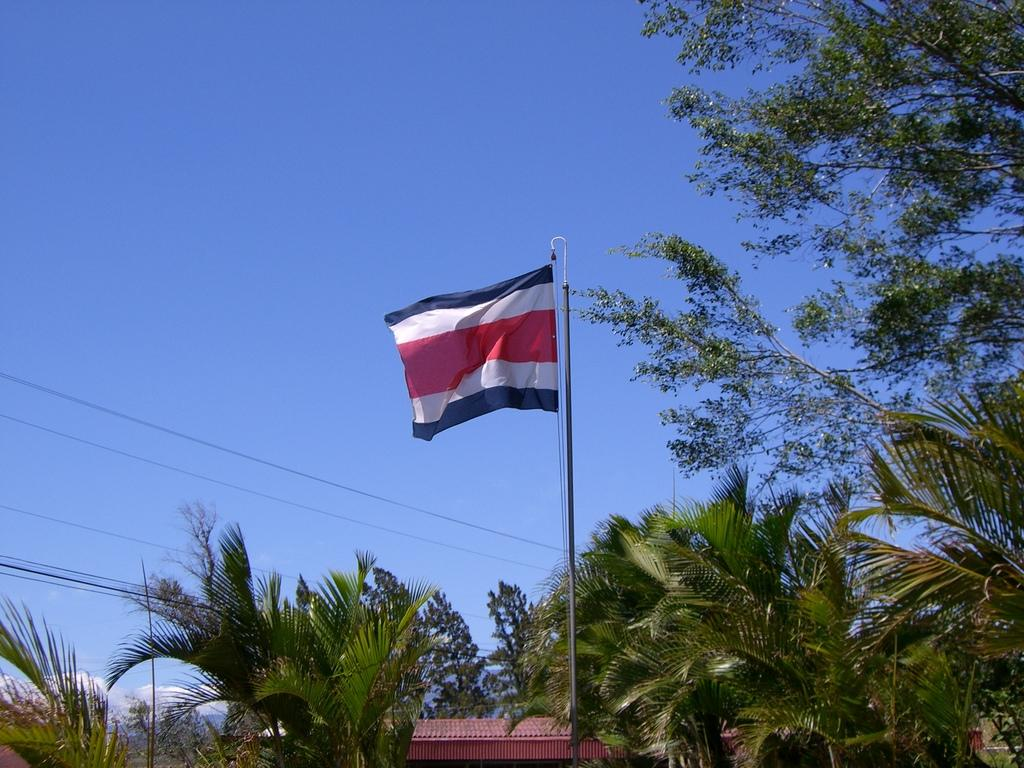What is placed on a pole in the image? There is a flag placed on a pole in the image. What can be seen in the background of the image? There is a group of trees and at least one building in the background of the image. What is visible in the sky in the image? The sky is visible in the background of the image. How many robins are perched on the flagpole in the image? There are no robins present in the image; the flagpole only has the flag on it. 